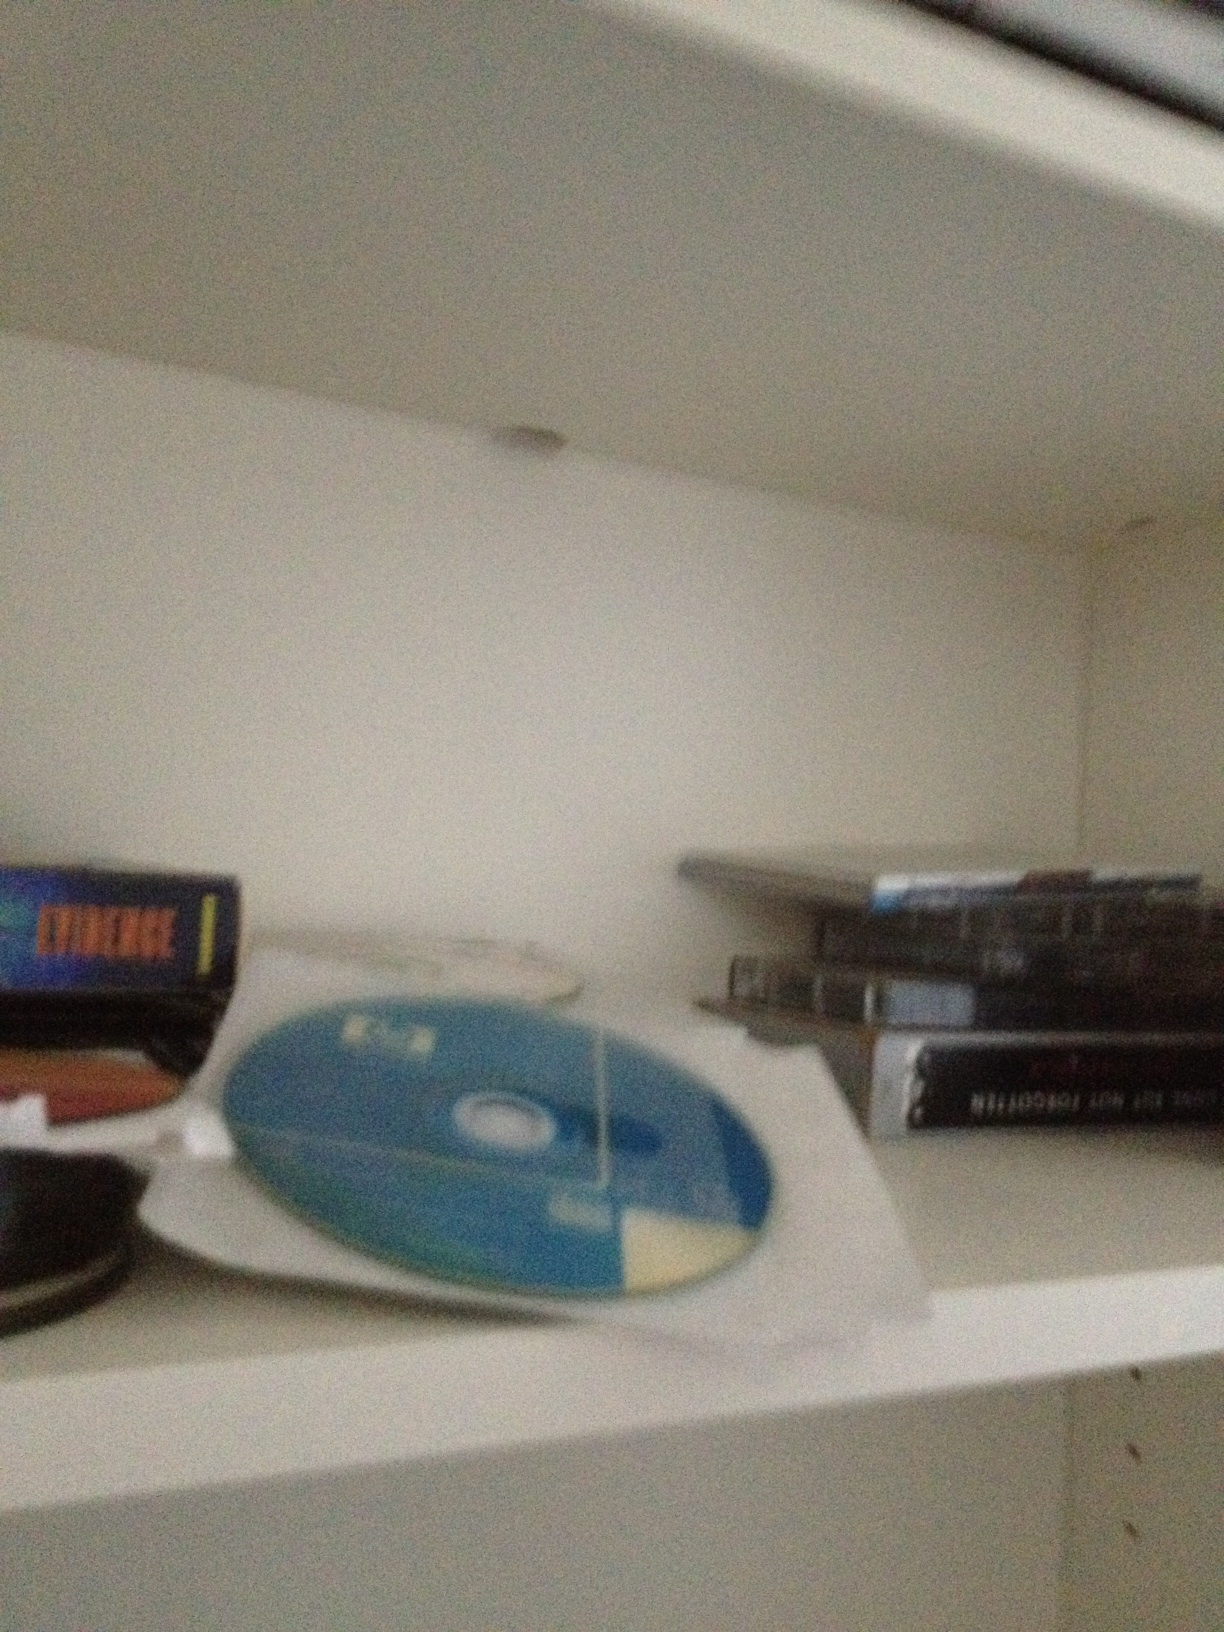If this photo was part of a movie scene, what would be happening? In this movie scene, the camera zooms in on the shelf, focusing on the CDs and DVDs. The protagonist, an aspiring musician, is seen frantically searching through the collection, looking for a particular inspiration for their new song. This moment of searching is tense and critical, as the right CD could spark the creativity needed to finish their debut album. Background music builds up to a crescendo as they finally find the disc that holds the key to their success. 